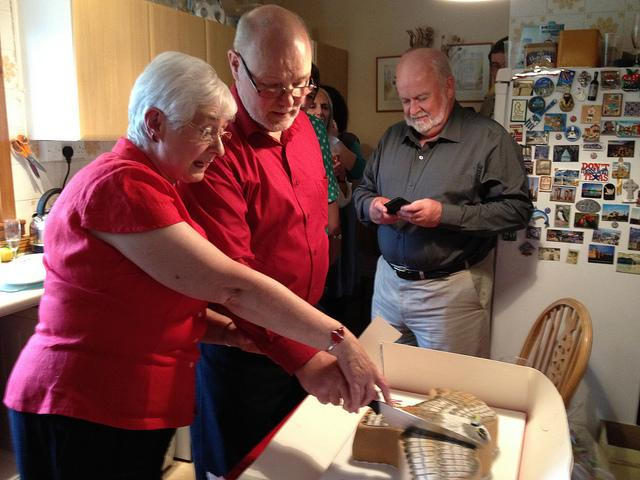What type of building are they in?

Choices:
A) hospital
B) commercial
C) school
D) residential residential 